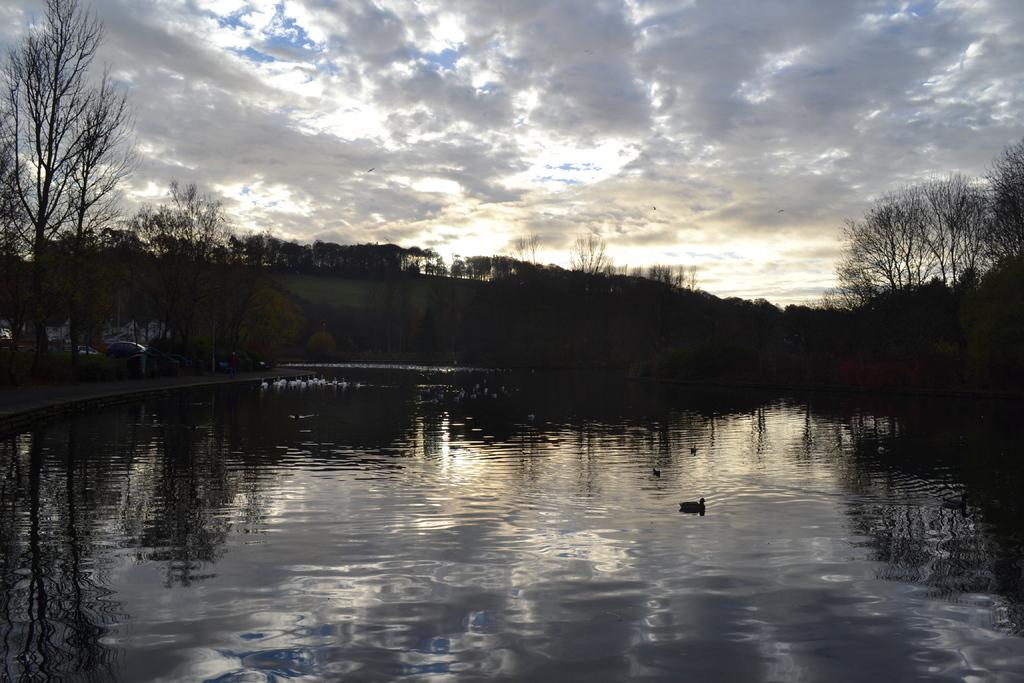What is the main element in the image? There is water in the image. What animals are present in the water? There are birds in the water. What type of vegetation can be seen in the image? There are trees visible in the image. What man-made objects are present in the image? There are vehicles in the image. What can be seen in the sky in the image? There are clouds in the image, and the sky is visible. What type of card is being used by the birds to communicate in the image? There is no card present in the image, and the birds are not shown communicating with each other. 